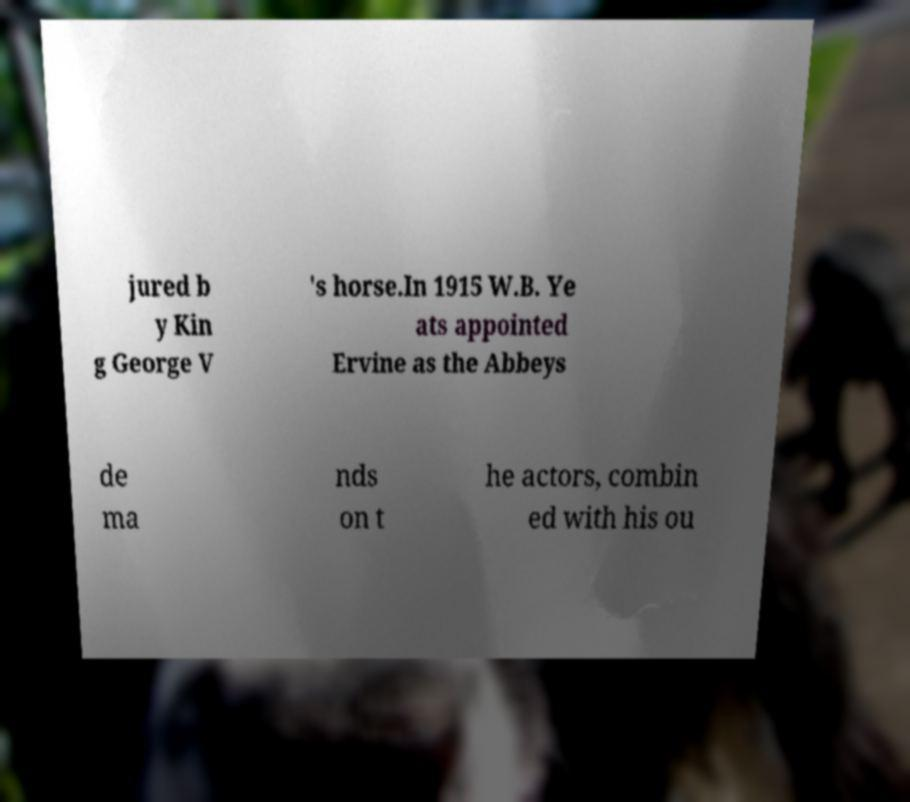For documentation purposes, I need the text within this image transcribed. Could you provide that? jured b y Kin g George V 's horse.In 1915 W.B. Ye ats appointed Ervine as the Abbeys de ma nds on t he actors, combin ed with his ou 